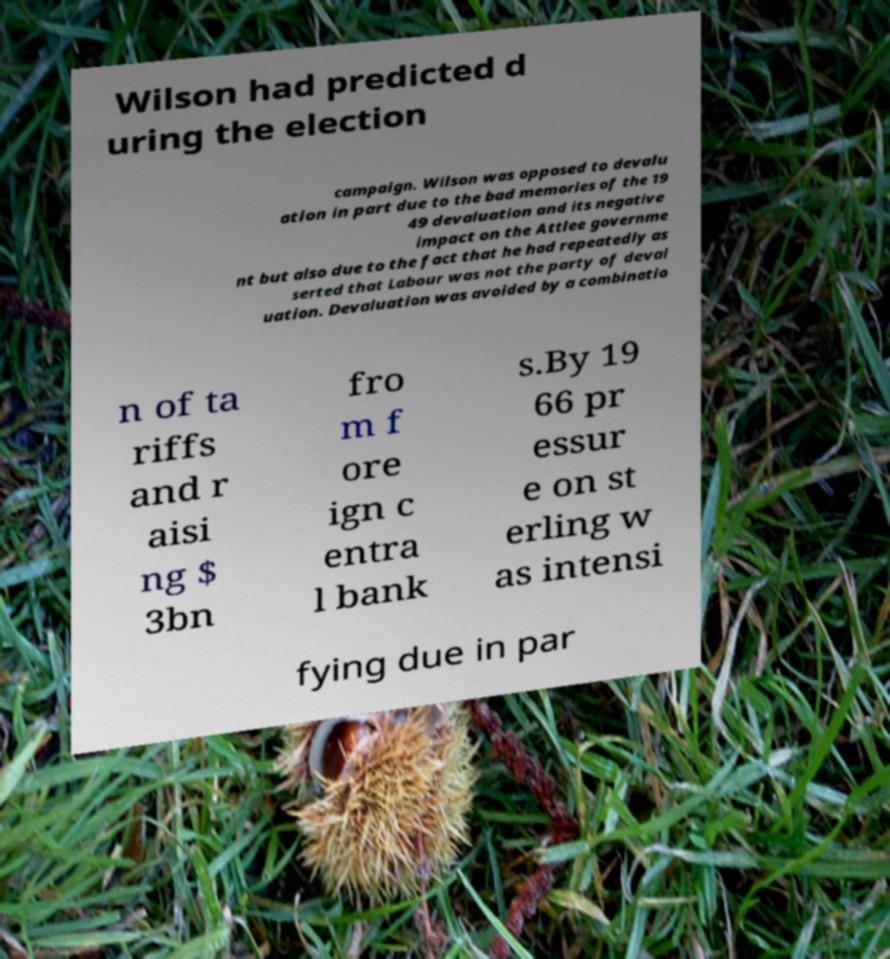For documentation purposes, I need the text within this image transcribed. Could you provide that? Wilson had predicted d uring the election campaign. Wilson was opposed to devalu ation in part due to the bad memories of the 19 49 devaluation and its negative impact on the Attlee governme nt but also due to the fact that he had repeatedly as serted that Labour was not the party of deval uation. Devaluation was avoided by a combinatio n of ta riffs and r aisi ng $ 3bn fro m f ore ign c entra l bank s.By 19 66 pr essur e on st erling w as intensi fying due in par 